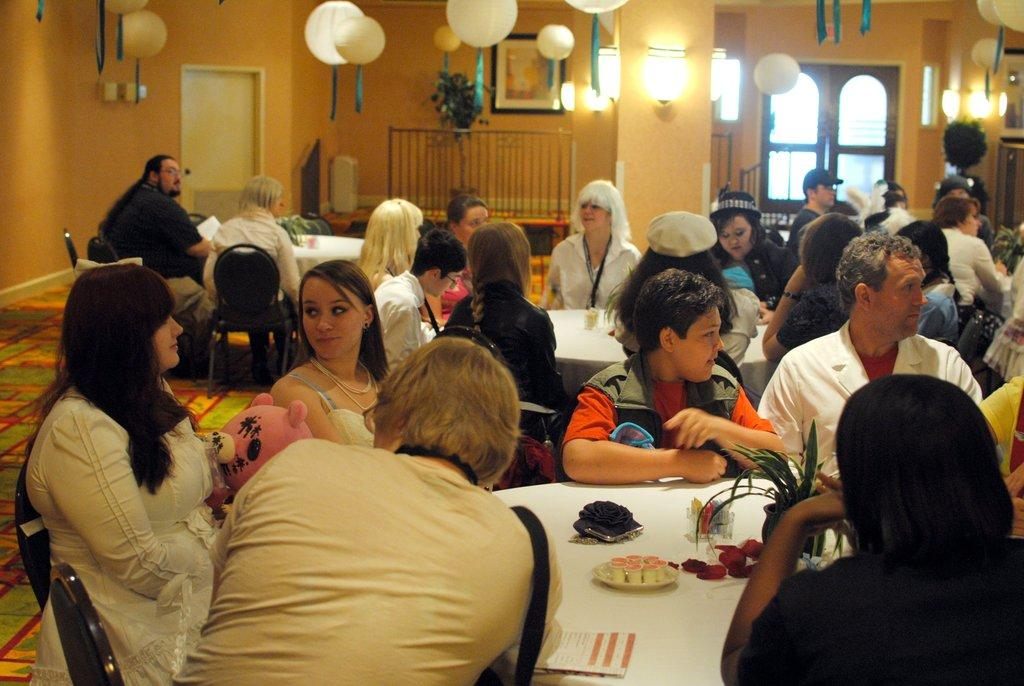How many people are in the image? There is a group of people in the image. What are the people doing in the image? The people are sitting in front of a table. What can be seen on the table in the image? There is a flower vase on the table, and there are objects on the table. What type of decoration is present in the room? There are balloon decorations in the room. What type of body is being displayed on the stage in the image? There is no stage or body present in the image; it features a group of people sitting in front of a table with balloon decorations. 